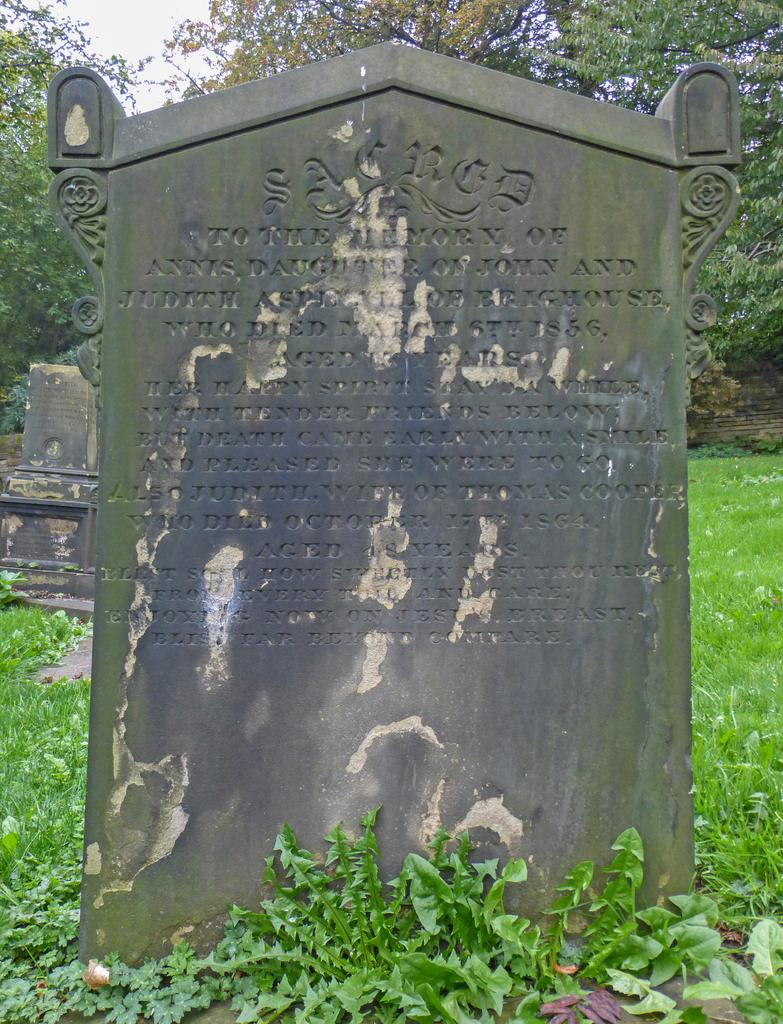What can be seen in the image that represents burial sites? There are gravestones in the image. What information is provided on the gravestones? The gravestones have text on them. What type of vegetation is present on the ground in the image? There is grass on the ground in the image. What can be seen in the distance in the image? There are trees in the background of the image. How would you describe the weather based on the sky in the image? The sky is cloudy in the image. What type of porter is carrying a statement in the image? There is no porter or statement present in the image. What type of picture is hanging on the wall in the image? There is no picture hanging on the wall in the image. 